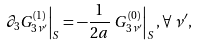Convert formula to latex. <formula><loc_0><loc_0><loc_500><loc_500>\left . \partial _ { 3 } G ^ { ( 1 ) } _ { 3 \nu ^ { \prime } } \right | _ { S } = - \frac { 1 } { 2 a } \left . G ^ { ( 0 ) } _ { 3 \nu ^ { \prime } } \right | _ { S } , \forall \, \nu ^ { \prime } ,</formula> 